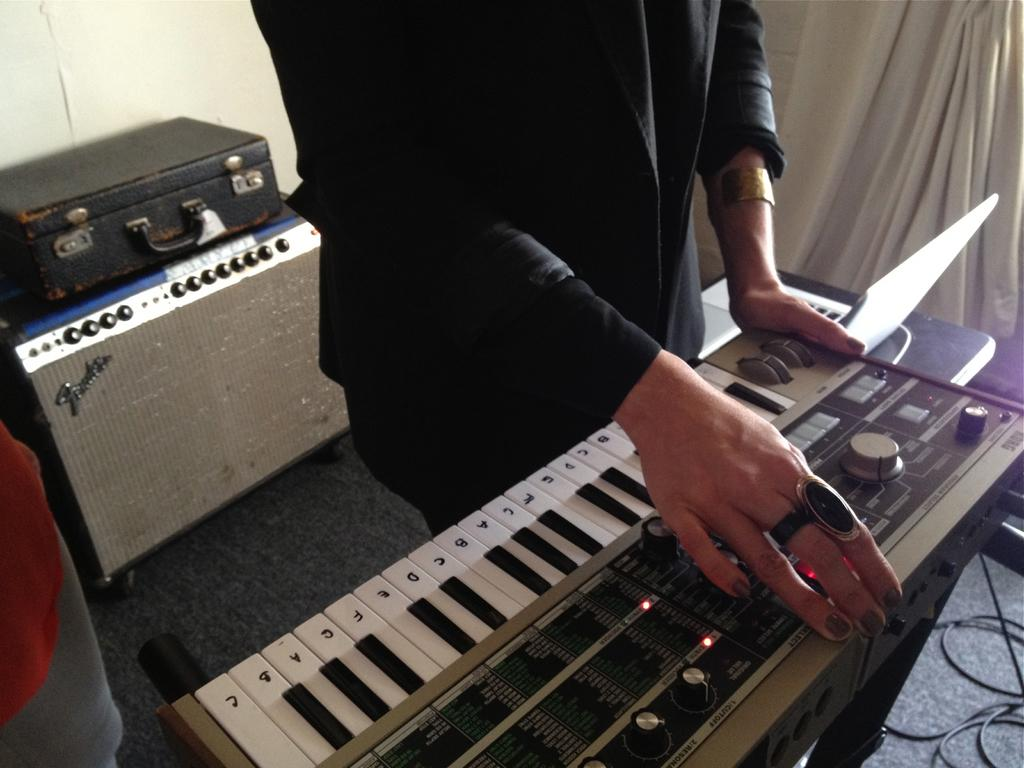Who or what is the main subject in the image? There is a person in the image. What is the person standing in front of? The person is standing in front of a piano. Are there any other objects visible in the image? Yes, there is a suitcase visible in the image. What type of desk can be seen in the image? There is no desk present in the image. Is the person in the image an actor? The image does not provide information about the person's profession, so it cannot be determined if they are an actor. 